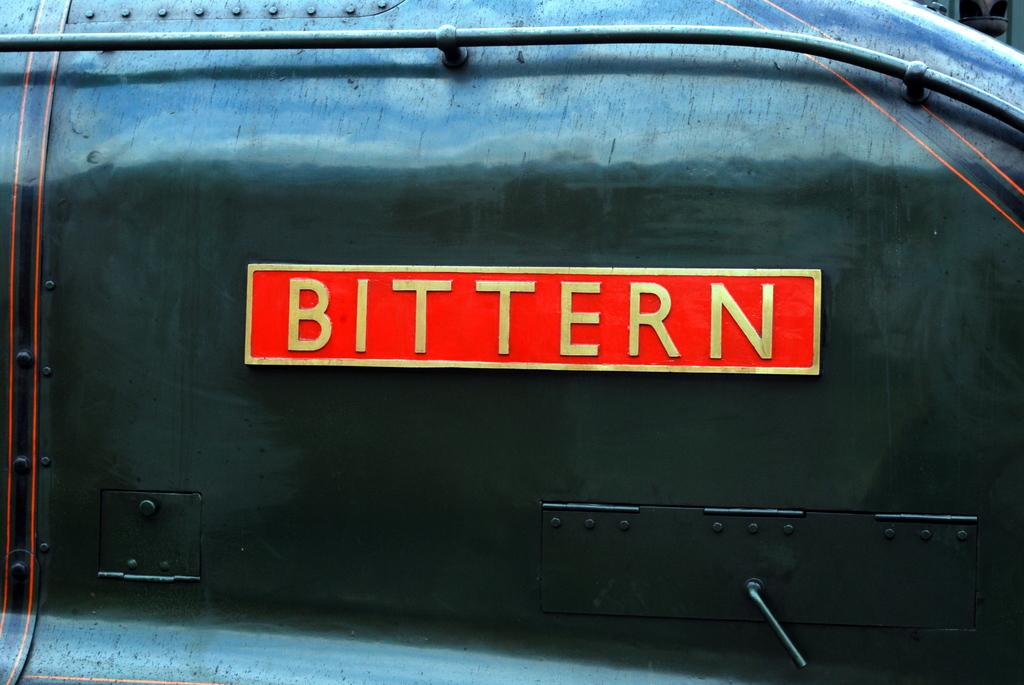Provide a one-sentence caption for the provided image. A photo of a machine that says Bittern. 